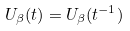<formula> <loc_0><loc_0><loc_500><loc_500>U _ { \beta } ( t ) = U _ { \beta } ( t ^ { - 1 } )</formula> 